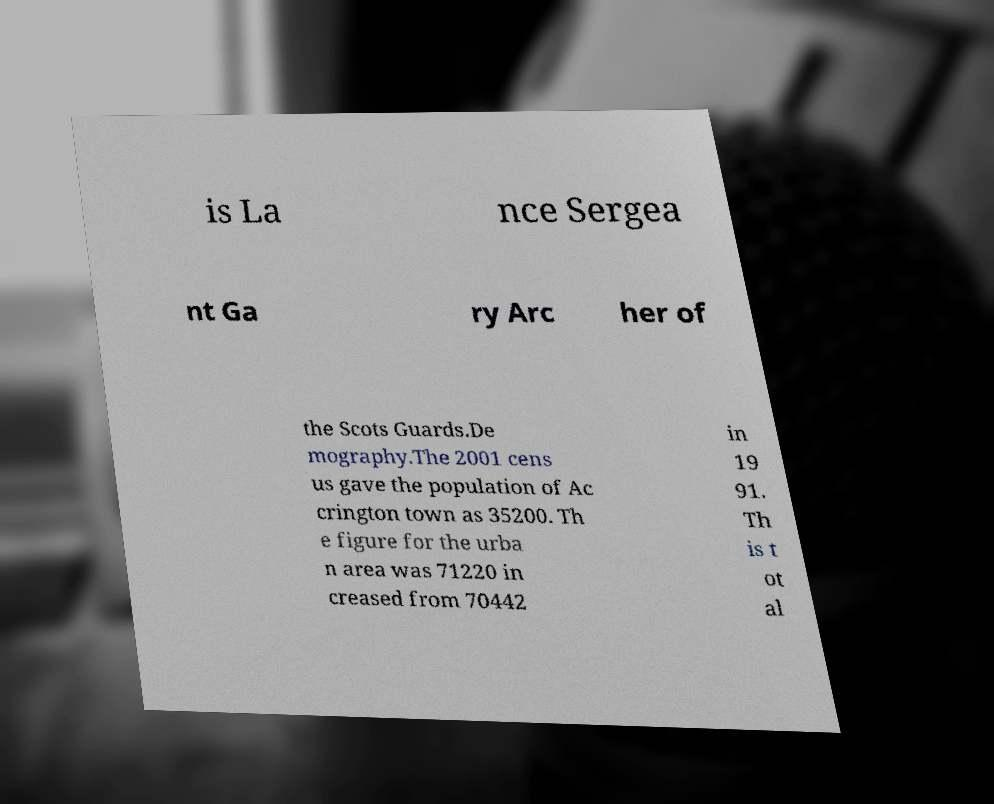Could you assist in decoding the text presented in this image and type it out clearly? is La nce Sergea nt Ga ry Arc her of the Scots Guards.De mography.The 2001 cens us gave the population of Ac crington town as 35200. Th e figure for the urba n area was 71220 in creased from 70442 in 19 91. Th is t ot al 